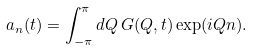Convert formula to latex. <formula><loc_0><loc_0><loc_500><loc_500>a _ { n } ( t ) = \int _ { - \pi } ^ { \pi } d Q \, G ( Q , t ) \exp ( i Q n ) .</formula> 